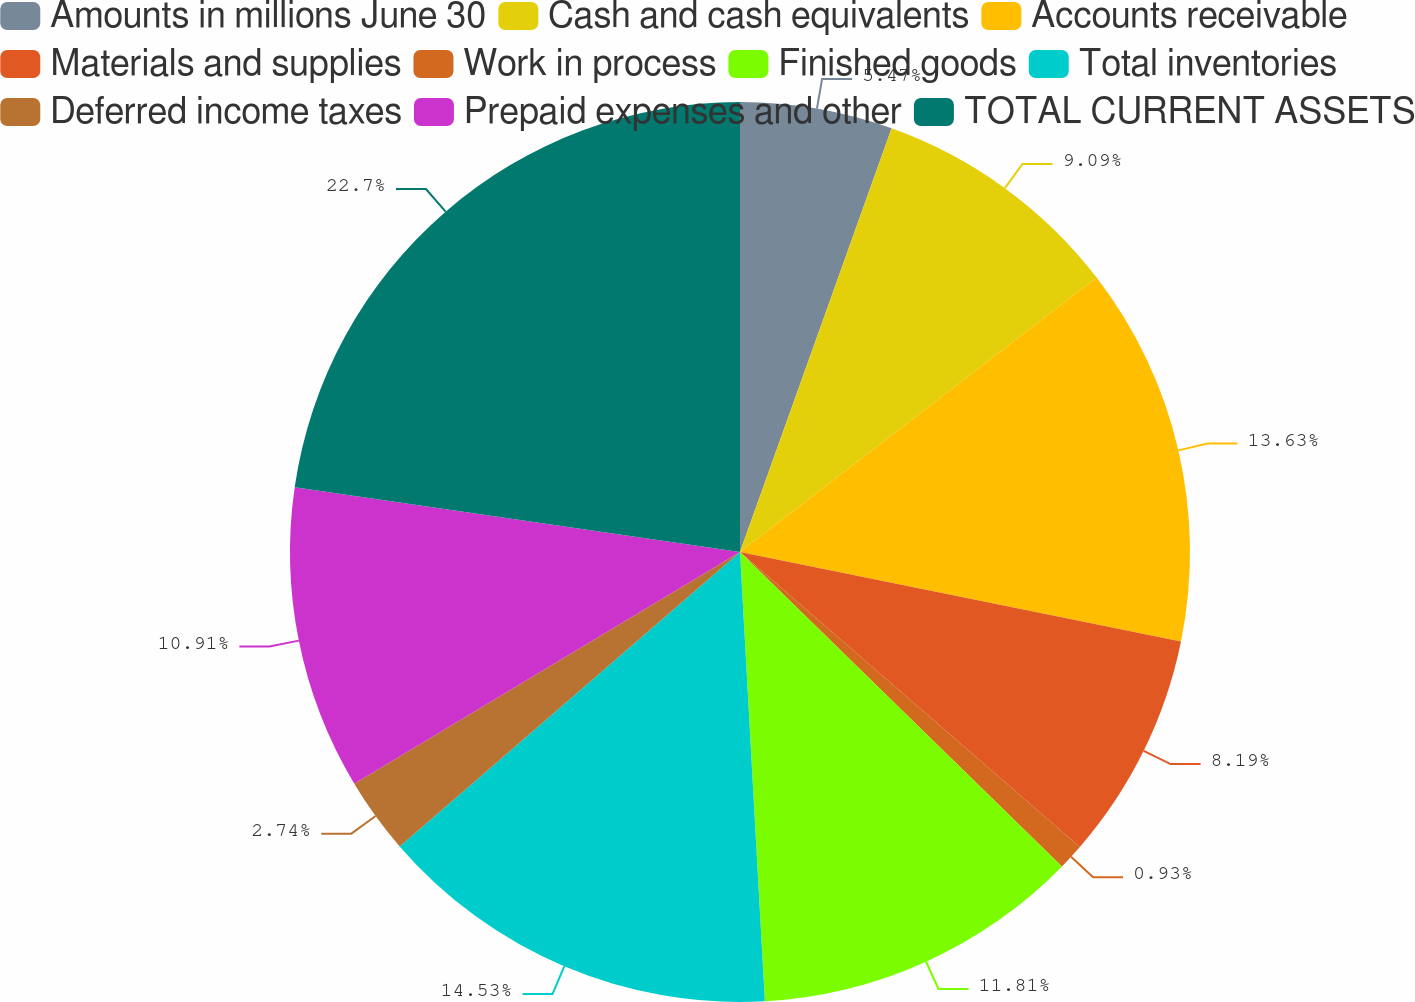Convert chart. <chart><loc_0><loc_0><loc_500><loc_500><pie_chart><fcel>Amounts in millions June 30<fcel>Cash and cash equivalents<fcel>Accounts receivable<fcel>Materials and supplies<fcel>Work in process<fcel>Finished goods<fcel>Total inventories<fcel>Deferred income taxes<fcel>Prepaid expenses and other<fcel>TOTAL CURRENT ASSETS<nl><fcel>5.47%<fcel>9.09%<fcel>13.63%<fcel>8.19%<fcel>0.93%<fcel>11.81%<fcel>14.53%<fcel>2.74%<fcel>10.91%<fcel>22.7%<nl></chart> 